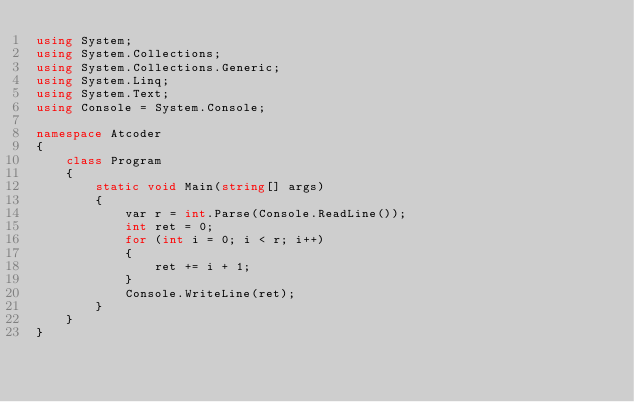Convert code to text. <code><loc_0><loc_0><loc_500><loc_500><_C#_>using System;
using System.Collections;
using System.Collections.Generic;
using System.Linq;
using System.Text;
using Console = System.Console;

namespace Atcoder
{
    class Program
    {
        static void Main(string[] args)
        {
            var r = int.Parse(Console.ReadLine());
            int ret = 0;
            for (int i = 0; i < r; i++)
            {
                ret += i + 1;
            }
            Console.WriteLine(ret);
        }
    }
}</code> 